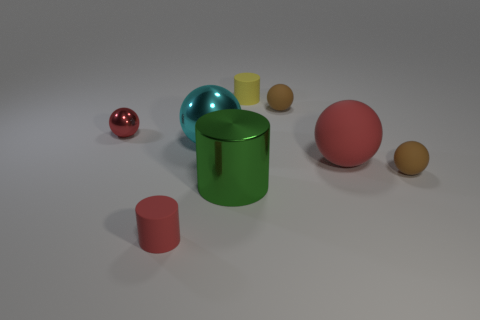How many things are either tiny brown rubber spheres that are behind the large red object or balls on the left side of the big rubber thing?
Keep it short and to the point. 3. Is the number of large red rubber spheres in front of the green thing the same as the number of red things that are in front of the small red metal ball?
Your answer should be compact. No. There is a matte thing that is left of the tiny matte cylinder that is behind the big green cylinder; what shape is it?
Keep it short and to the point. Cylinder. Are there any tiny yellow objects of the same shape as the big green object?
Your answer should be very brief. Yes. How many small red objects are there?
Provide a succinct answer. 2. Does the tiny red object that is right of the small metal ball have the same material as the green object?
Your response must be concise. No. Are there any cyan metal balls that have the same size as the red matte cylinder?
Keep it short and to the point. No. There is a big red rubber thing; is it the same shape as the shiny thing to the right of the cyan ball?
Your answer should be very brief. No. Is there a ball on the left side of the brown rubber object in front of the red ball that is behind the big cyan ball?
Provide a succinct answer. Yes. The green cylinder has what size?
Your answer should be compact. Large. 